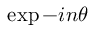Convert formula to latex. <formula><loc_0><loc_0><loc_500><loc_500>\exp { - i n \theta }</formula> 